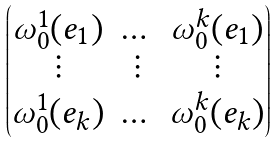Convert formula to latex. <formula><loc_0><loc_0><loc_500><loc_500>\begin{pmatrix} \omega _ { 0 } ^ { 1 } ( e _ { 1 } ) & \dots & \omega _ { 0 } ^ { k } ( e _ { 1 } ) \\ \vdots & \vdots & \vdots \\ \omega _ { 0 } ^ { 1 } ( e _ { k } ) & \dots & \omega _ { 0 } ^ { k } ( e _ { k } ) \end{pmatrix}</formula> 